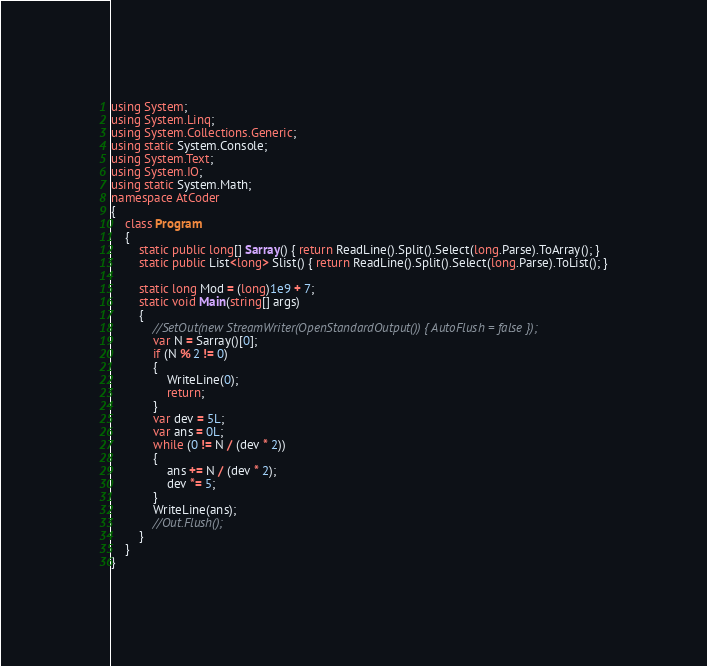Convert code to text. <code><loc_0><loc_0><loc_500><loc_500><_C#_>using System;
using System.Linq;
using System.Collections.Generic;
using static System.Console;
using System.Text;
using System.IO;
using static System.Math;
namespace AtCoder
{
    class Program
    {
        static public long[] Sarray() { return ReadLine().Split().Select(long.Parse).ToArray(); }
        static public List<long> Slist() { return ReadLine().Split().Select(long.Parse).ToList(); }

        static long Mod = (long)1e9 + 7;
        static void Main(string[] args)
        {
            //SetOut(new StreamWriter(OpenStandardOutput()) { AutoFlush = false });
            var N = Sarray()[0];
            if (N % 2 != 0)
            {
                WriteLine(0);
                return;
            }
            var dev = 5L;
            var ans = 0L;
            while (0 != N / (dev * 2))
            {
                ans += N / (dev * 2);
                dev *= 5;
            }
            WriteLine(ans);
            //Out.Flush();
        }
    }
}</code> 